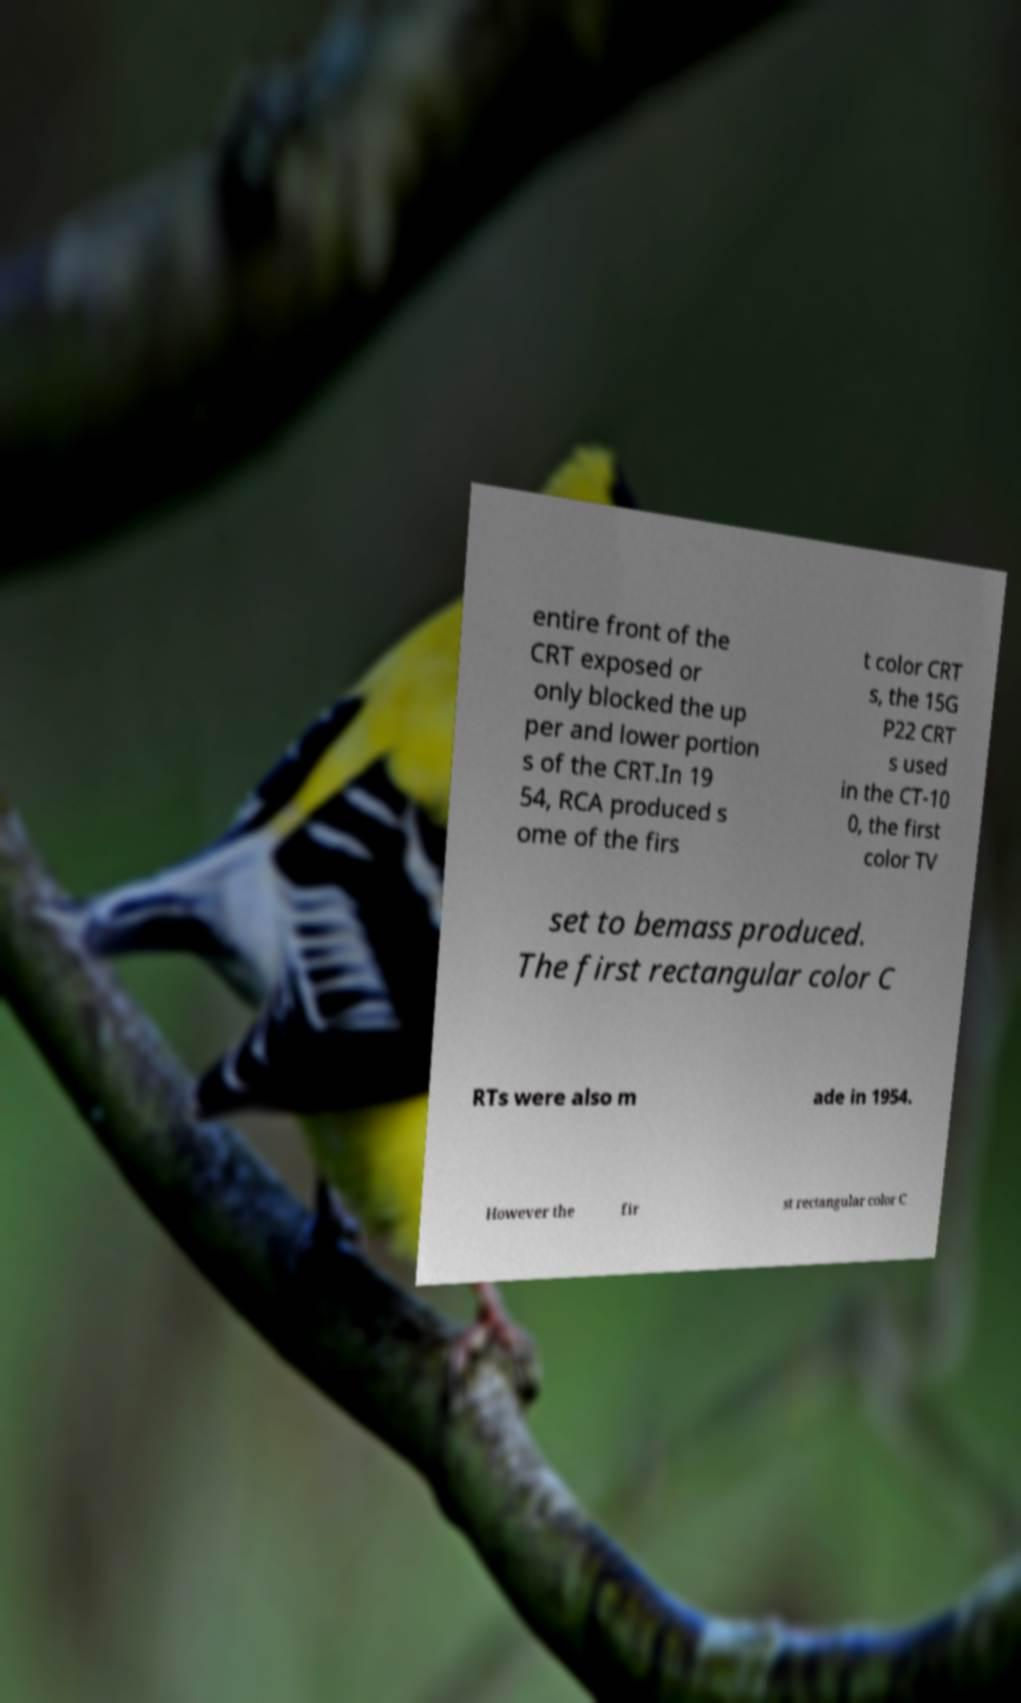Could you assist in decoding the text presented in this image and type it out clearly? entire front of the CRT exposed or only blocked the up per and lower portion s of the CRT.In 19 54, RCA produced s ome of the firs t color CRT s, the 15G P22 CRT s used in the CT-10 0, the first color TV set to bemass produced. The first rectangular color C RTs were also m ade in 1954. However the fir st rectangular color C 